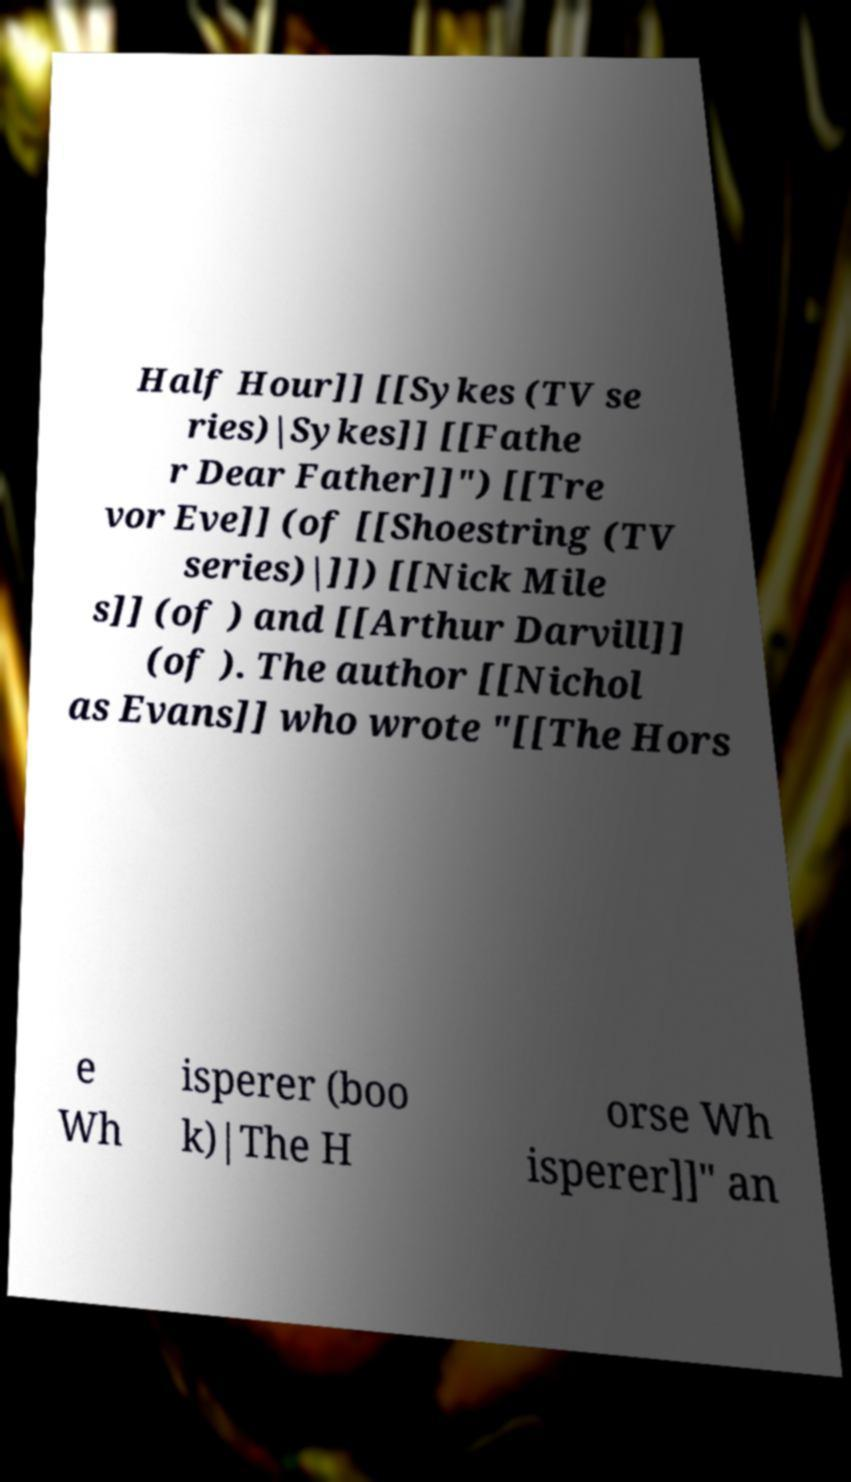Can you accurately transcribe the text from the provided image for me? Half Hour]] [[Sykes (TV se ries)|Sykes]] [[Fathe r Dear Father]]") [[Tre vor Eve]] (of [[Shoestring (TV series)|]]) [[Nick Mile s]] (of ) and [[Arthur Darvill]] (of ). The author [[Nichol as Evans]] who wrote "[[The Hors e Wh isperer (boo k)|The H orse Wh isperer]]" an 